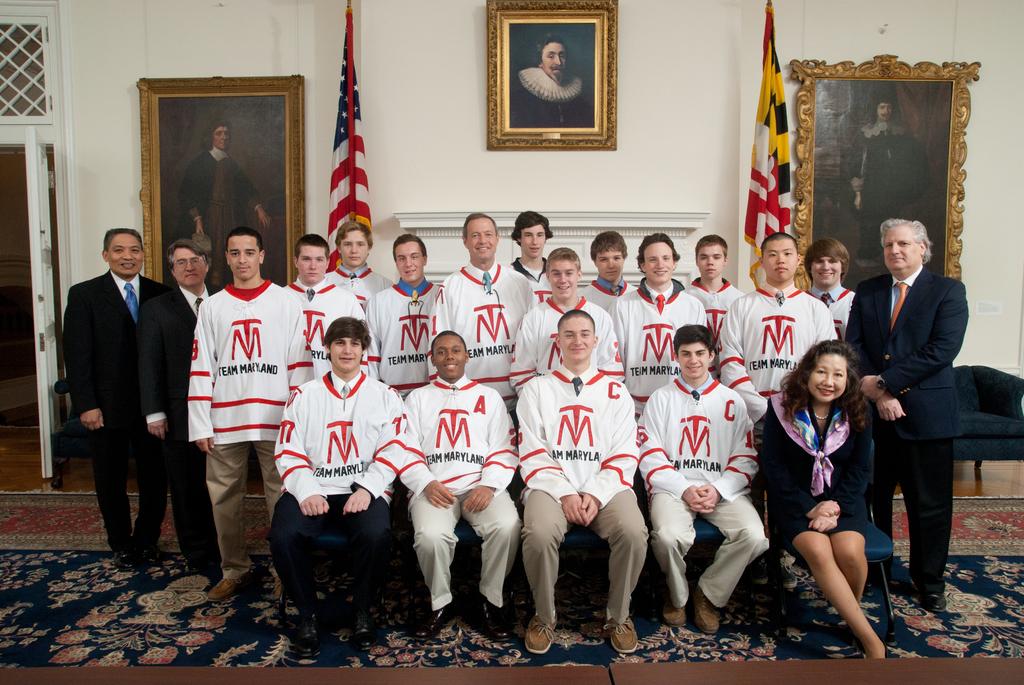What does it say on the team shirt?
Ensure brevity in your answer.  Team maryland. 